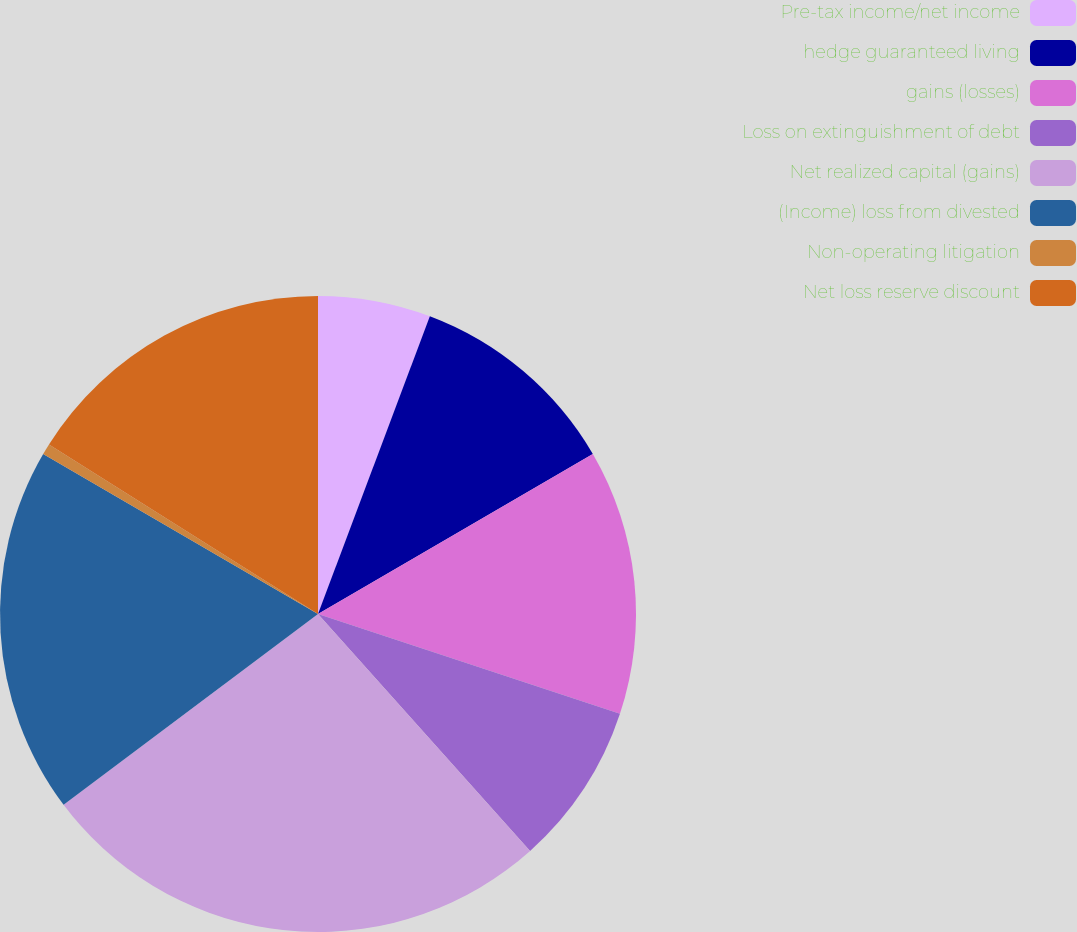Convert chart to OTSL. <chart><loc_0><loc_0><loc_500><loc_500><pie_chart><fcel>Pre-tax income/net income<fcel>hedge guaranteed living<fcel>gains (losses)<fcel>Loss on extinguishment of debt<fcel>Net realized capital (gains)<fcel>(Income) loss from divested<fcel>Non-operating litigation<fcel>Net loss reserve discount<nl><fcel>5.72%<fcel>10.89%<fcel>13.47%<fcel>8.3%<fcel>26.38%<fcel>18.63%<fcel>0.56%<fcel>16.05%<nl></chart> 